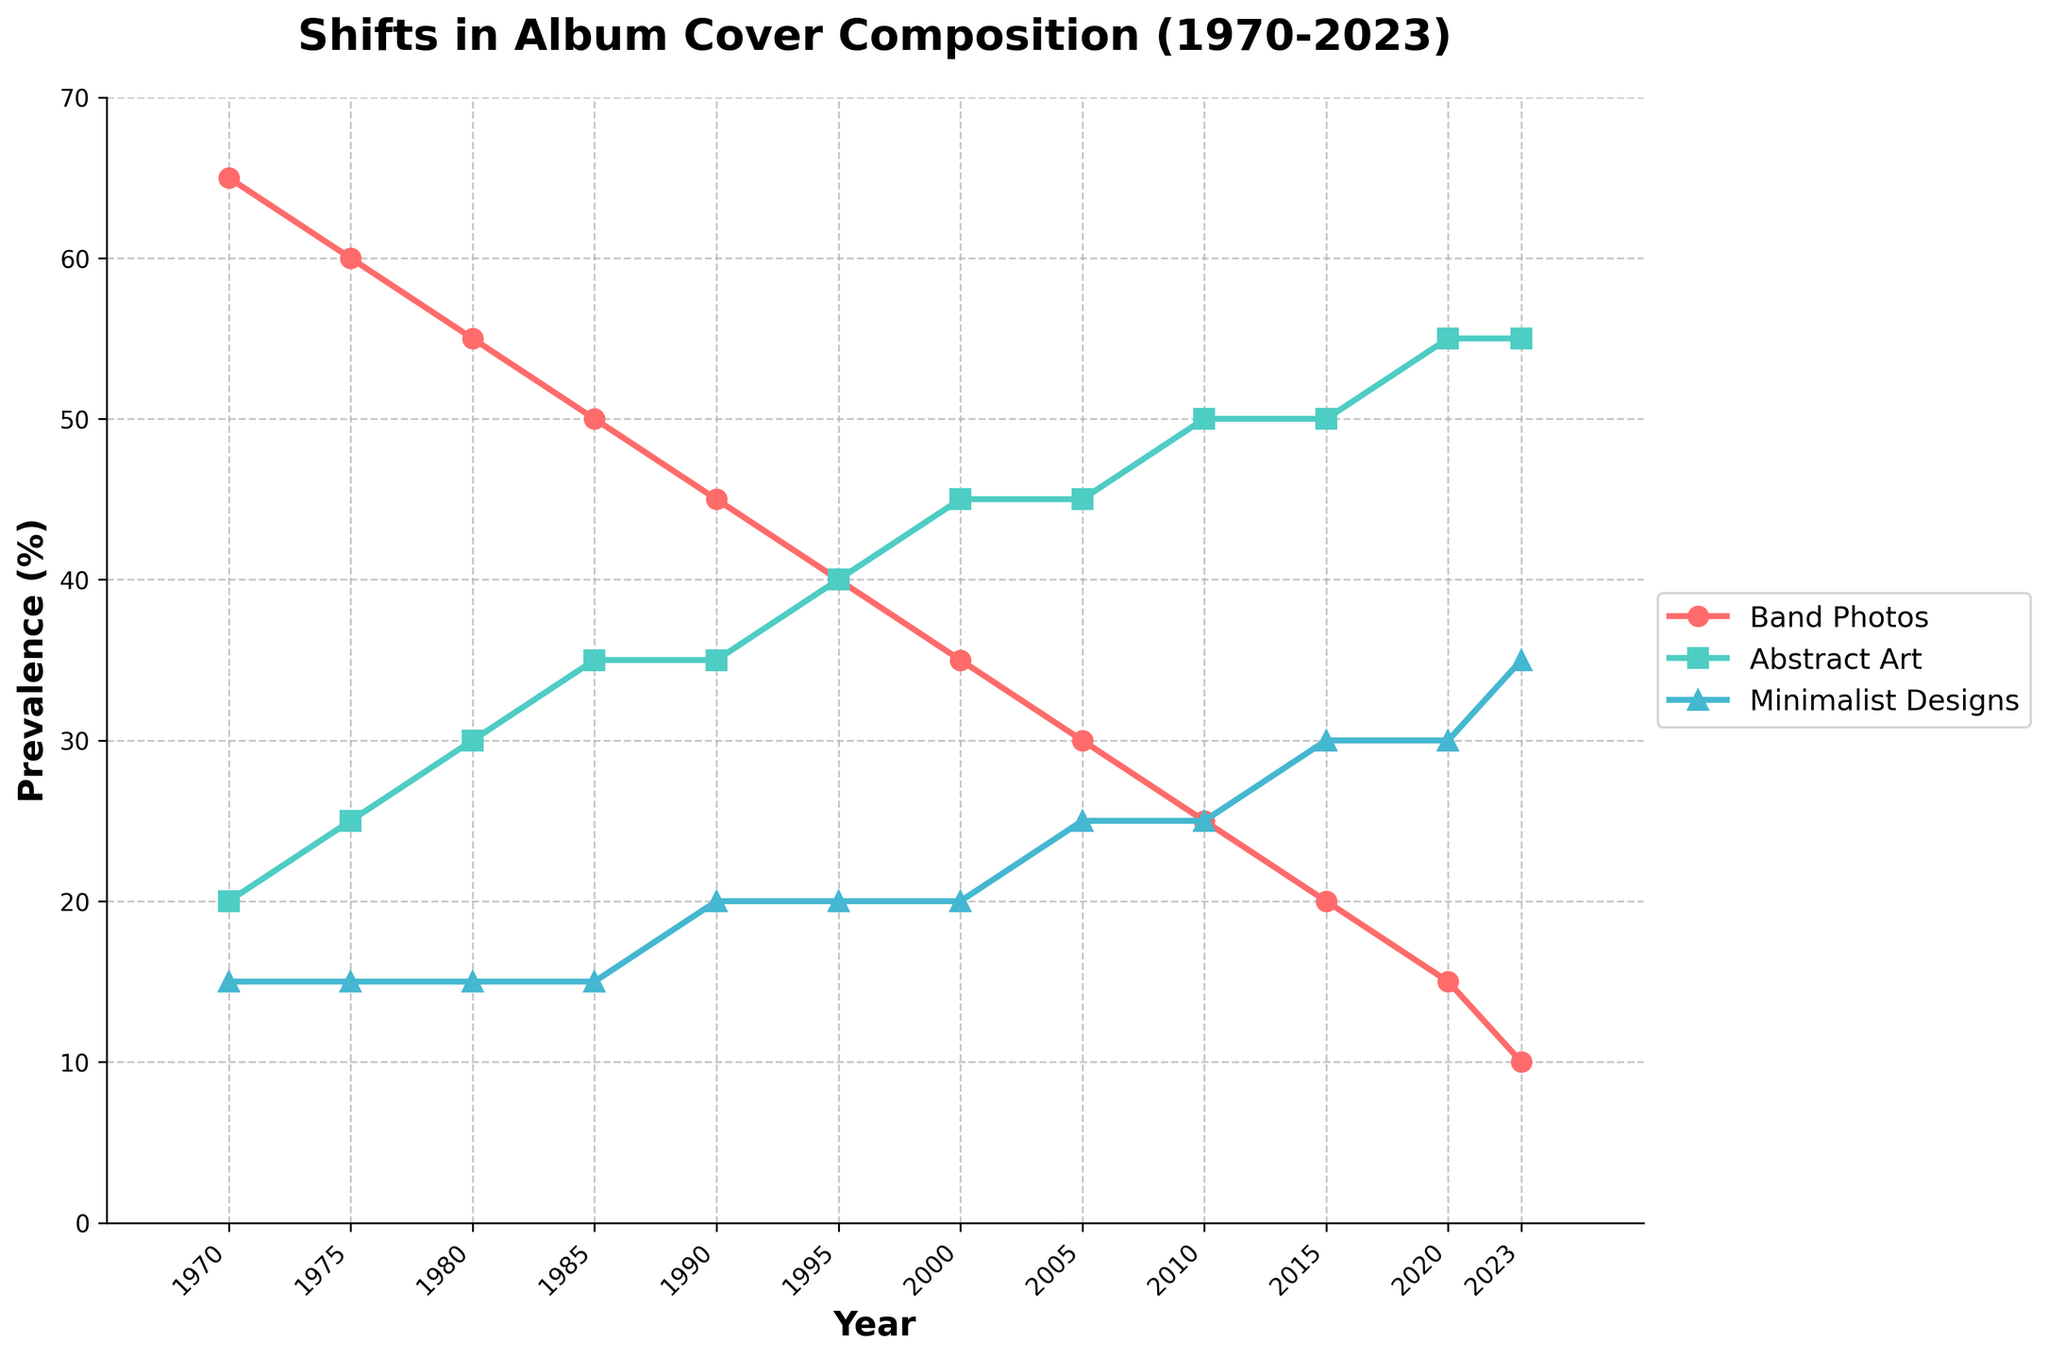What's the primary trend of band photos on album covers from 1970 to 2023? The prevalence of band photos on album covers steadily decreases from 65% in 1970 to 10% in 2023. This can be observed by following the red line marked with circles going downwards throughout the years.
Answer: Decreasing In which year did abstract art on album covers become more prevalent than band photos? In 1990, the percentage of abstract art on album covers (35%) became equal to band photos (45%) for the first time. After 1990, abstract art continues to remain higher than band photos in prevalence.
Answer: 1990 How does the prevalence of minimalist designs change from 1970 to 2023? The prevalence of minimalist designs on album covers shows a steady increase from 15% in 1970 to 35% in 2023. This is illustrated by the upward trend of the blue line marked with triangles.
Answer: Increasing During which period did the prevalence of band photos and abstract art both remain constant? From 1985 to 1990, the prevalence of band photos remains at 45%, and the prevalence of abstract art also stays level at 35%. This is shown by the flat segments of both the red and green lines in this period.
Answer: 1985 to 1990 What was the approximate difference in prevalence between abstract art and band photos in 2020? The prevalence of abstract art in 2020 was 55%, and for band photos, it was 15%. The difference can be calculated by subtracting the two values: 55% - 15% = 40%.
Answer: 40% Between which consecutive periods did minimalist designs see the largest increase in prevalence? The largest increase in prevalence for minimalist designs occurred between 2015 and 2023. It increased from 30% to 35%, which is a 5% increase. This is indicated by the steepest segment of the blue line.
Answer: 2015 to 2023 Which design style overtakes band photos in prevalence first, abstract art or minimalist designs, and in which year? Abstract art overtakes band photos first in 1995. Abstract art had 40% prevalence while band photos dropped to 40%. Minimalist designs only reached 20% in that year.
Answer: Abstract art in 1995 